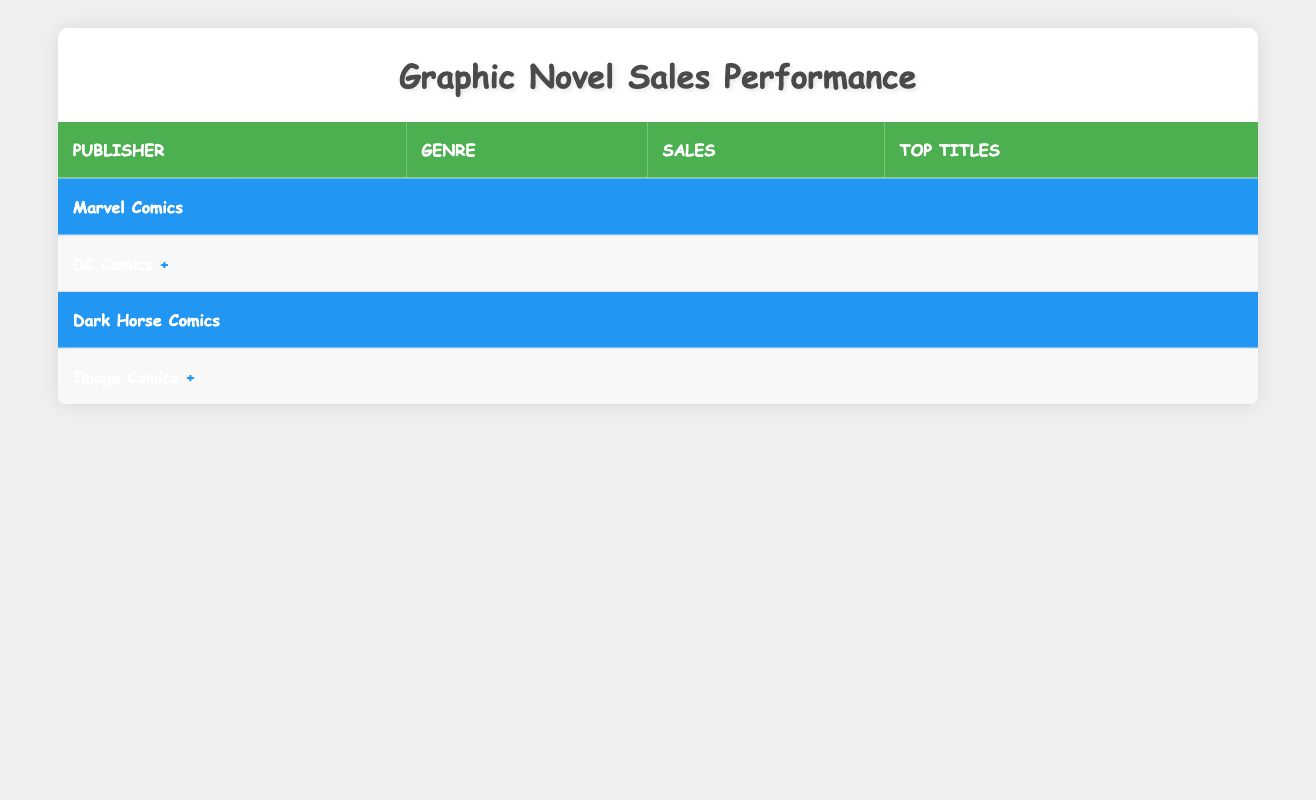What are the total sales of graphic novels published by Marvel Comics? The sales for Marvel Comics are listed under the Superhero and Fantasy genres, which total 800,000 and 450,000 respectively. To find the total sales, we add these two values: 800,000 + 450,000 = 1,250,000.
Answer: 1,250,000 Which publisher has the highest sales in the Superhero genre? Marvel Comics has sales of 800,000 in the Superhero genre, while DC Comics has sales of 900,000 in the same genre. Comparing these values, DC Comics has the higher sales with 900,000.
Answer: DC Comics What is the average sales of graphic novels across all genres? The total sales for each publisher are calculated as follows: Marvel (1,250,000) + DC (1,250,000) + Dark Horse (550,000) + Image (1,000,000) = 4,050,000. There are 8 data points (genres) in total across the publishers, so the average is 4,050,000 / 8 = 506,250.
Answer: 506,250 Is it true that Dark Horse Comics has more sales in the Horror genre than in Science Fiction? Dark Horse Comics has sales of 300,000 in the Science Fiction genre and 250,000 in the Horror genre. Since 300,000 is greater than 250,000, the assertion is not true.
Answer: No Which genre contributes the least to total sales across all publishers? To find the least contributing genre, we review the sales figures: Superhero (1,700,000), Fantasy (850,000), Mystery (350,000), Science Fiction (300,000), and Horror (250,000). The genre Horror has the smallest sales figure at 250,000.
Answer: Horror 